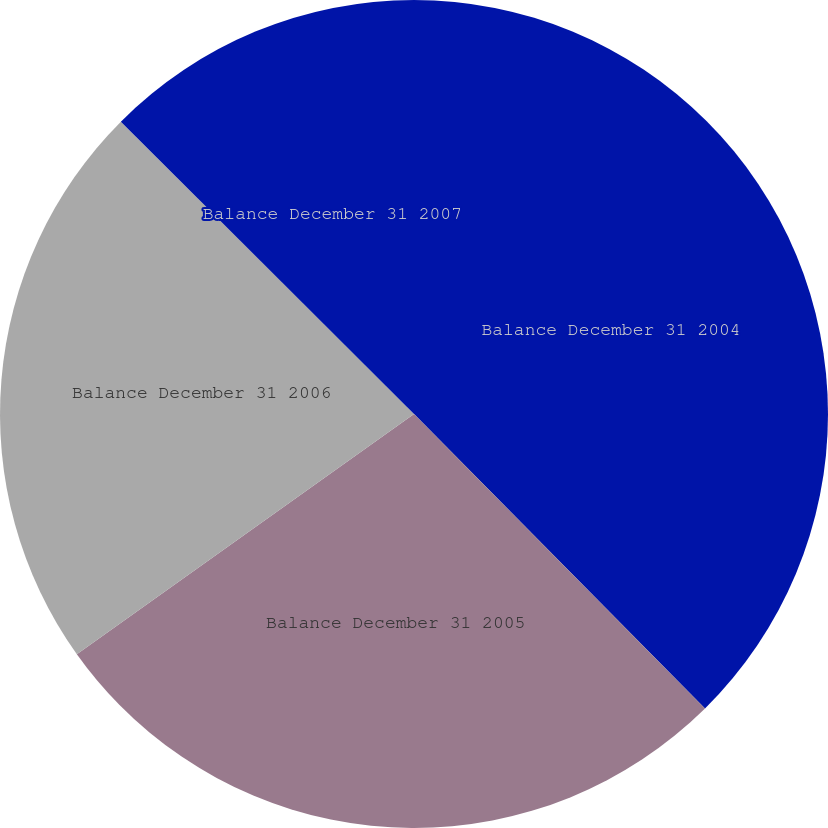Convert chart to OTSL. <chart><loc_0><loc_0><loc_500><loc_500><pie_chart><fcel>Balance December 31 2004<fcel>Balance December 31 2005<fcel>Balance December 31 2006<fcel>Balance December 31 2007<nl><fcel>37.59%<fcel>27.55%<fcel>22.33%<fcel>12.52%<nl></chart> 